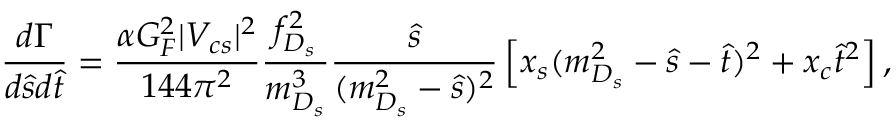<formula> <loc_0><loc_0><loc_500><loc_500>\frac { d \Gamma } { d \hat { s } d \hat { t } } = \frac { \alpha G _ { F } ^ { 2 } | V _ { c s } | ^ { 2 } } { 1 4 4 \pi ^ { 2 } } \frac { f _ { D _ { s } } ^ { 2 } } { m _ { D _ { s } } ^ { 3 } } \frac { \hat { s } } { ( m _ { D _ { s } } ^ { 2 } - \hat { s } ) ^ { 2 } } \left [ x _ { s } ( m _ { D _ { s } } ^ { 2 } - \hat { s } - \hat { t } ) ^ { 2 } + x _ { c } \hat { t } ^ { 2 } \right ] ,</formula> 